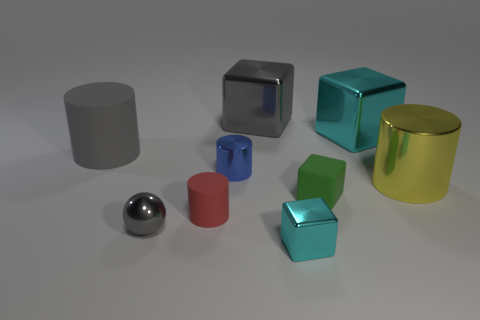Subtract all purple blocks. Subtract all red balls. How many blocks are left? 4 Subtract all balls. How many objects are left? 8 Subtract 0 blue spheres. How many objects are left? 9 Subtract all gray rubber cubes. Subtract all blue shiny cylinders. How many objects are left? 8 Add 8 tiny matte cylinders. How many tiny matte cylinders are left? 9 Add 5 spheres. How many spheres exist? 6 